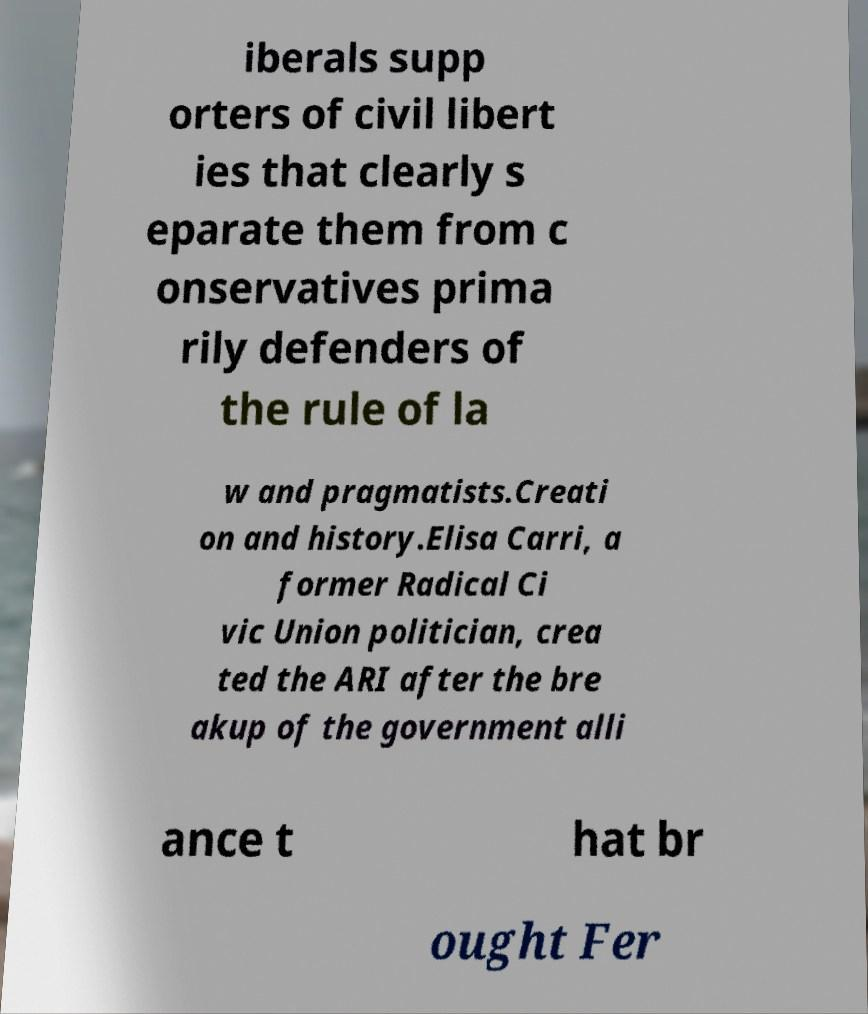Could you extract and type out the text from this image? iberals supp orters of civil libert ies that clearly s eparate them from c onservatives prima rily defenders of the rule of la w and pragmatists.Creati on and history.Elisa Carri, a former Radical Ci vic Union politician, crea ted the ARI after the bre akup of the government alli ance t hat br ought Fer 